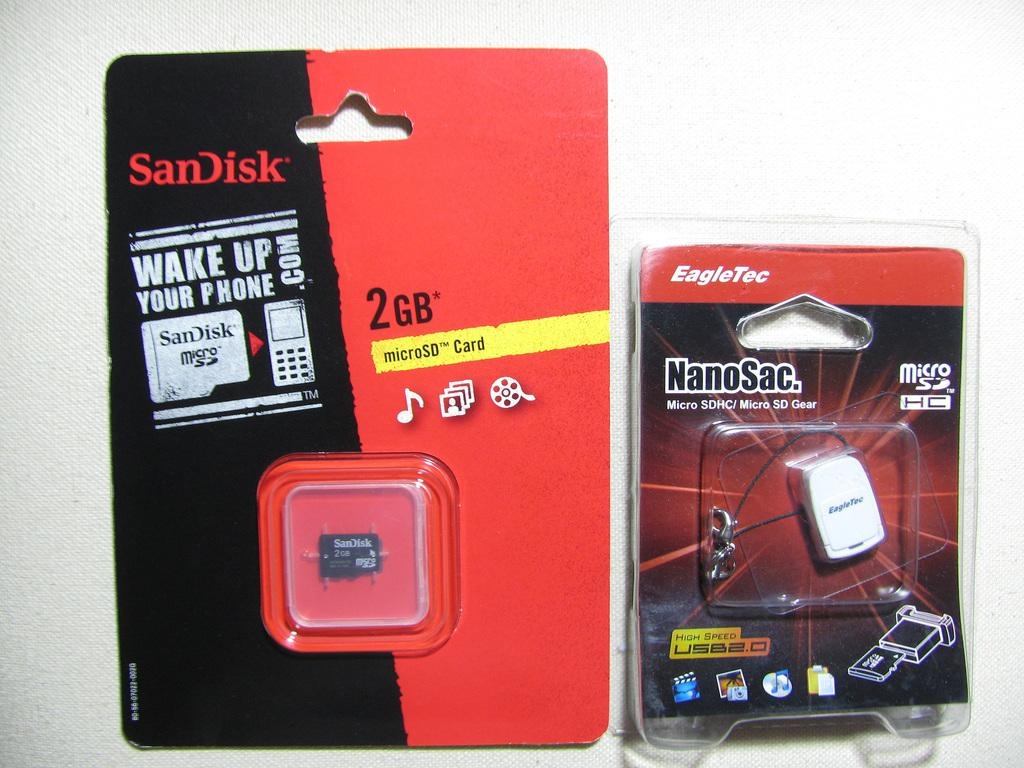<image>
Share a concise interpretation of the image provided. a package with an item that says Nanosac on it 